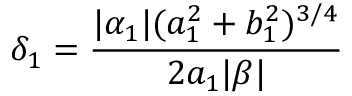Convert formula to latex. <formula><loc_0><loc_0><loc_500><loc_500>\delta _ { 1 } = \frac { | \alpha _ { 1 } | ( a _ { 1 } ^ { 2 } + b _ { 1 } ^ { 2 } ) ^ { 3 / 4 } } { 2 a _ { 1 } | \beta | }</formula> 